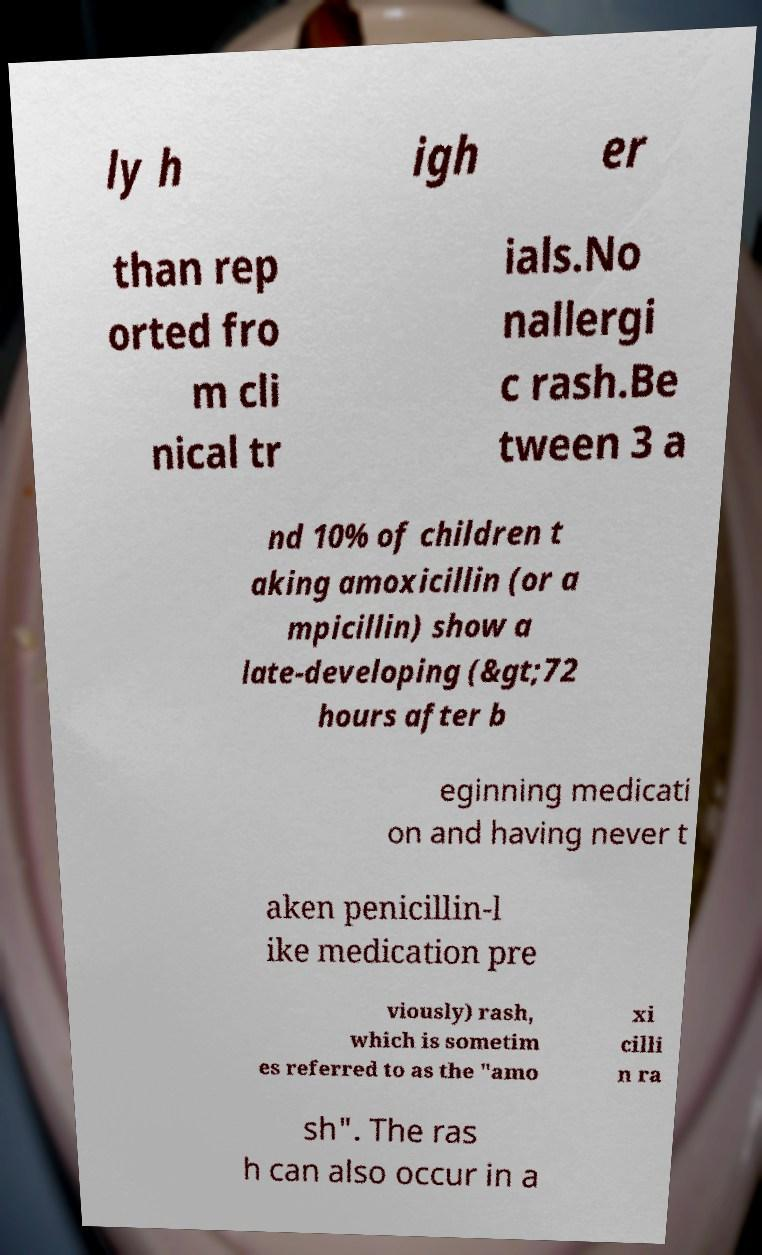Can you accurately transcribe the text from the provided image for me? ly h igh er than rep orted fro m cli nical tr ials.No nallergi c rash.Be tween 3 a nd 10% of children t aking amoxicillin (or a mpicillin) show a late-developing (&gt;72 hours after b eginning medicati on and having never t aken penicillin-l ike medication pre viously) rash, which is sometim es referred to as the "amo xi cilli n ra sh". The ras h can also occur in a 